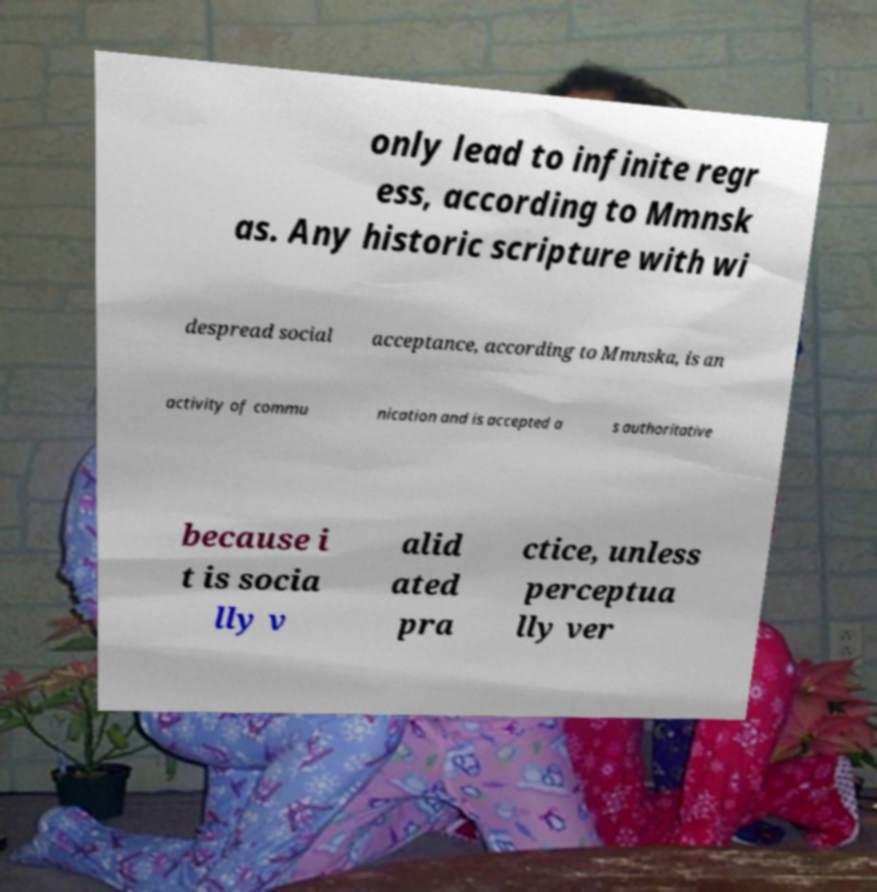Please read and relay the text visible in this image. What does it say? only lead to infinite regr ess, according to Mmnsk as. Any historic scripture with wi despread social acceptance, according to Mmnska, is an activity of commu nication and is accepted a s authoritative because i t is socia lly v alid ated pra ctice, unless perceptua lly ver 